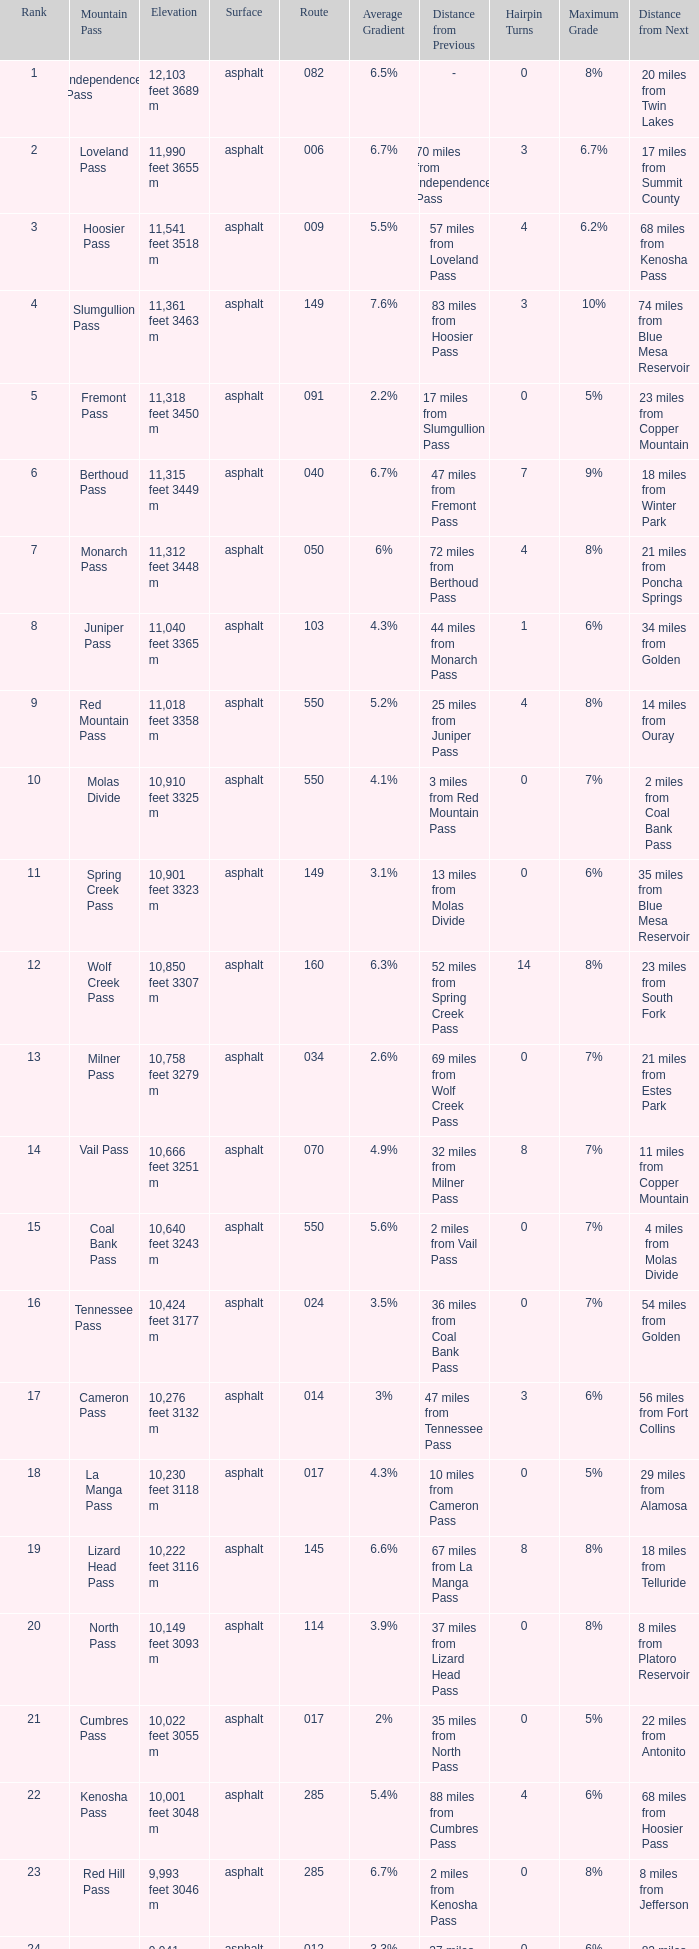What is the Elevation of the mountain on Route 62? 8,970 feet 2734 m. 